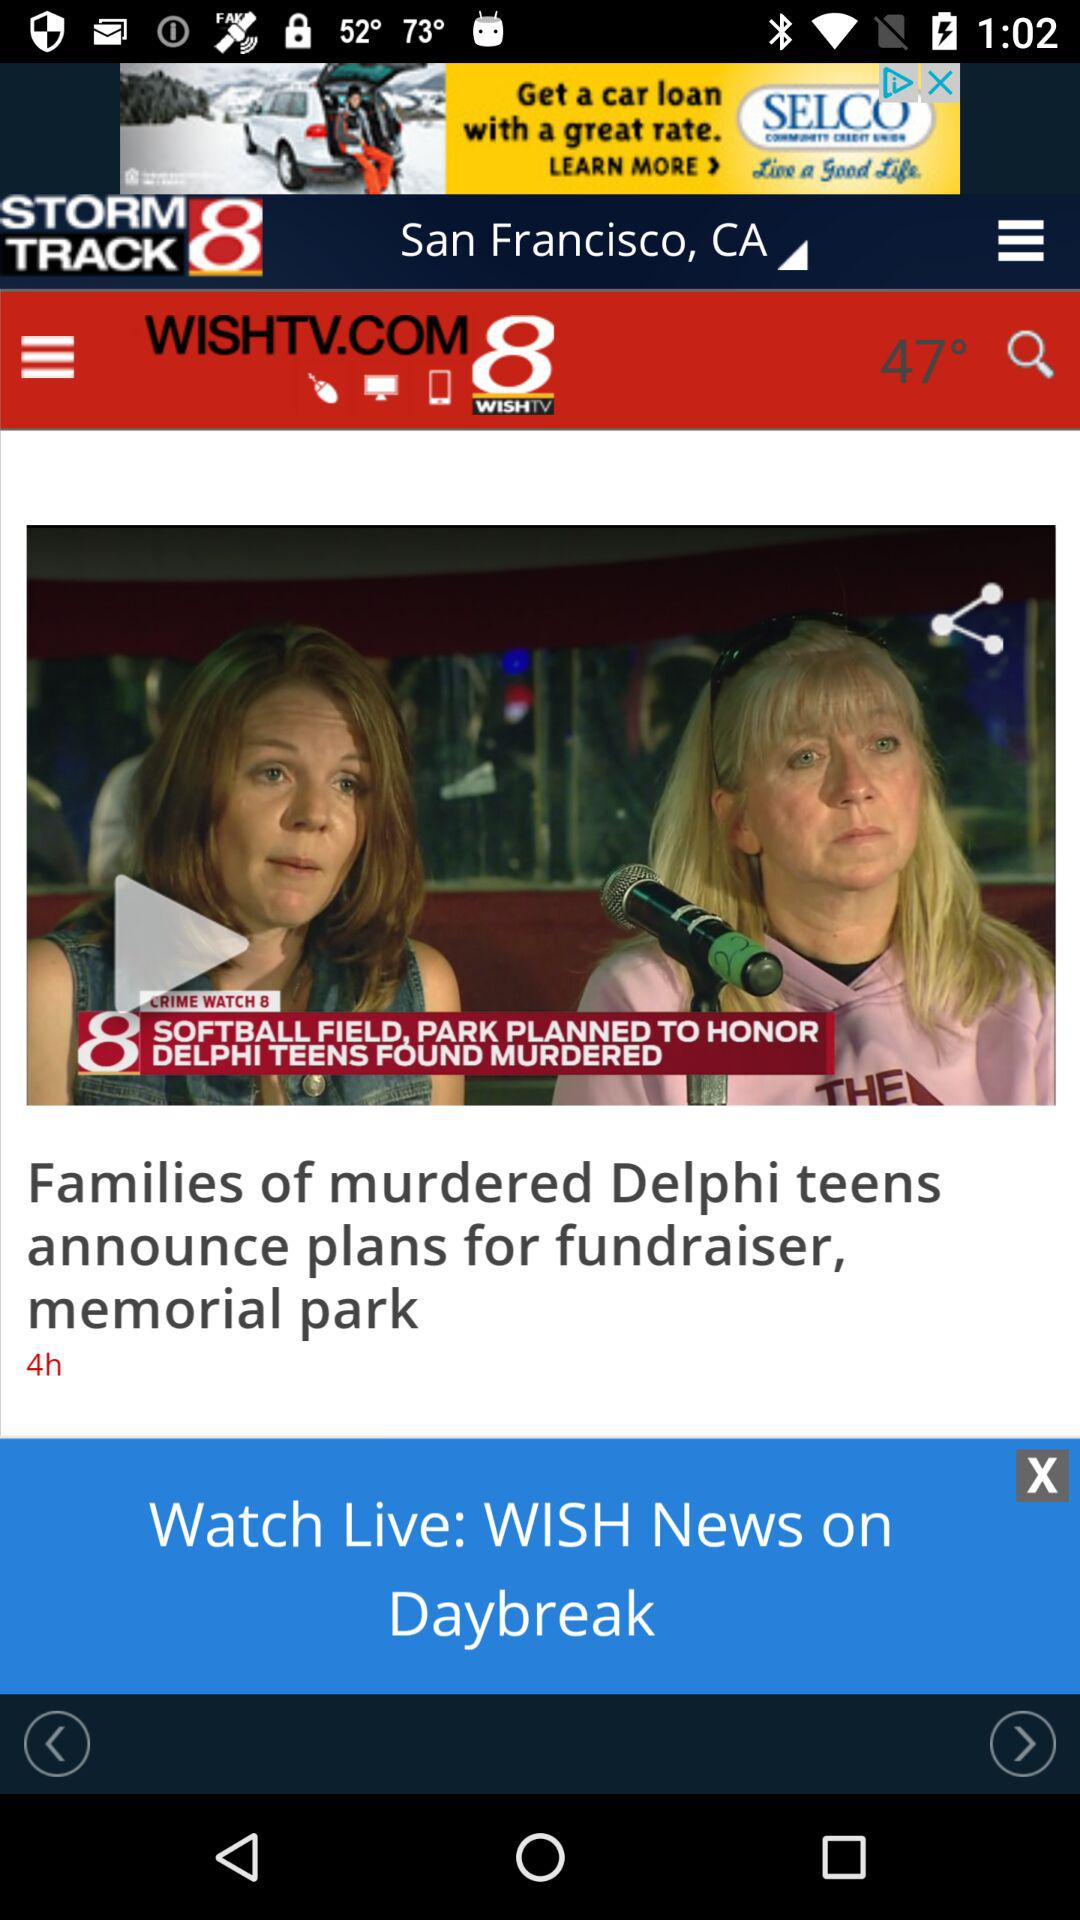What is the news channel name? The news channel name is "WISH-TV (channel 8)". 